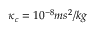Convert formula to latex. <formula><loc_0><loc_0><loc_500><loc_500>\kappa _ { c } = 1 0 ^ { - 8 } m s ^ { 2 } / k g</formula> 